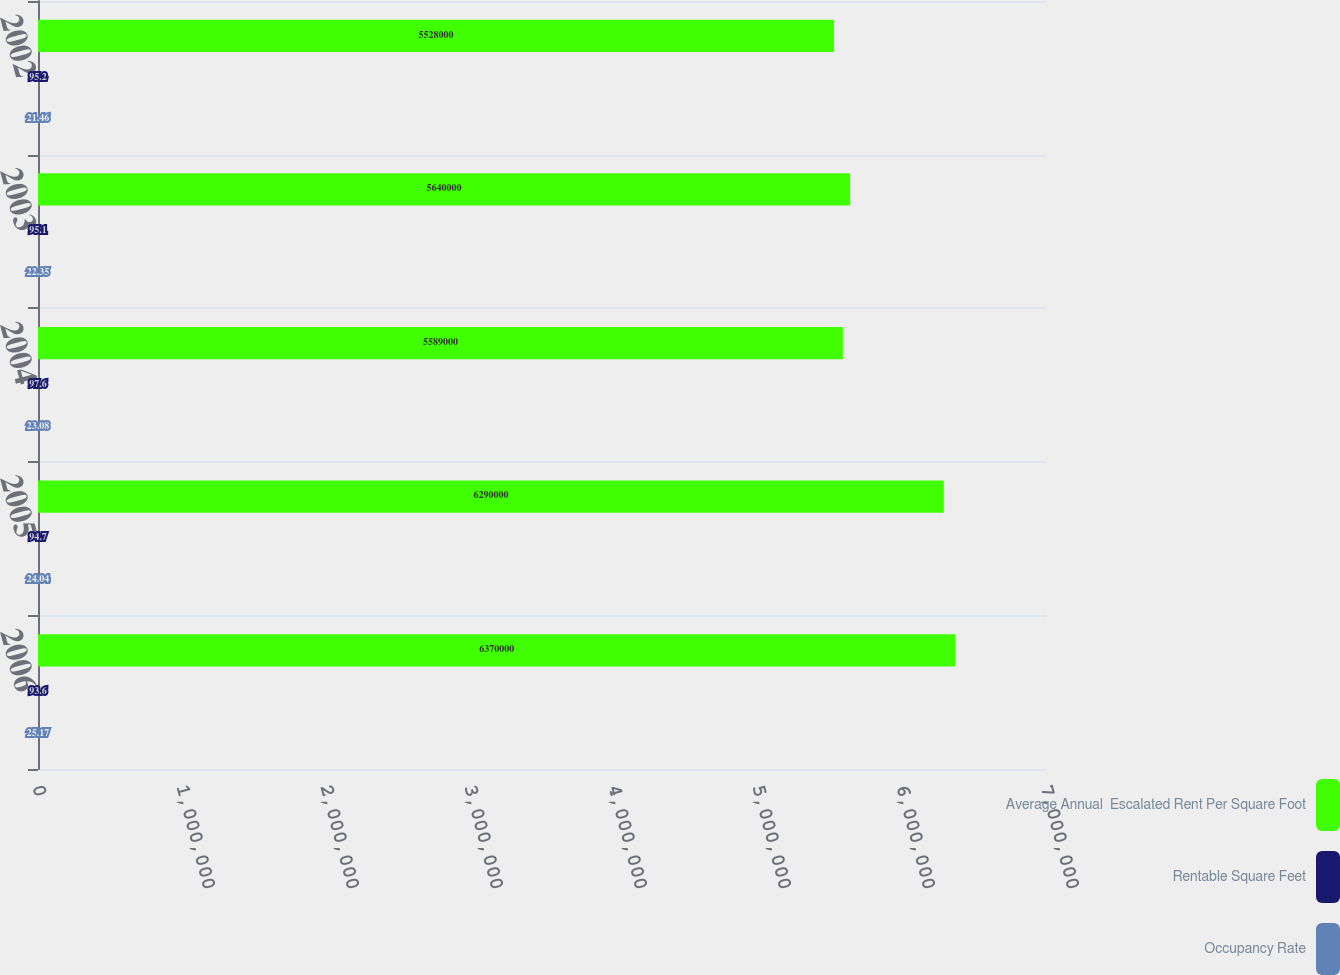Convert chart to OTSL. <chart><loc_0><loc_0><loc_500><loc_500><stacked_bar_chart><ecel><fcel>2006<fcel>2005<fcel>2004<fcel>2003<fcel>2002<nl><fcel>Average Annual  Escalated Rent Per Square Foot<fcel>6.37e+06<fcel>6.29e+06<fcel>5.589e+06<fcel>5.64e+06<fcel>5.528e+06<nl><fcel>Rentable Square Feet<fcel>93.6<fcel>94.7<fcel>97.6<fcel>95.1<fcel>95.2<nl><fcel>Occupancy Rate<fcel>25.17<fcel>24.04<fcel>23.08<fcel>22.35<fcel>21.46<nl></chart> 